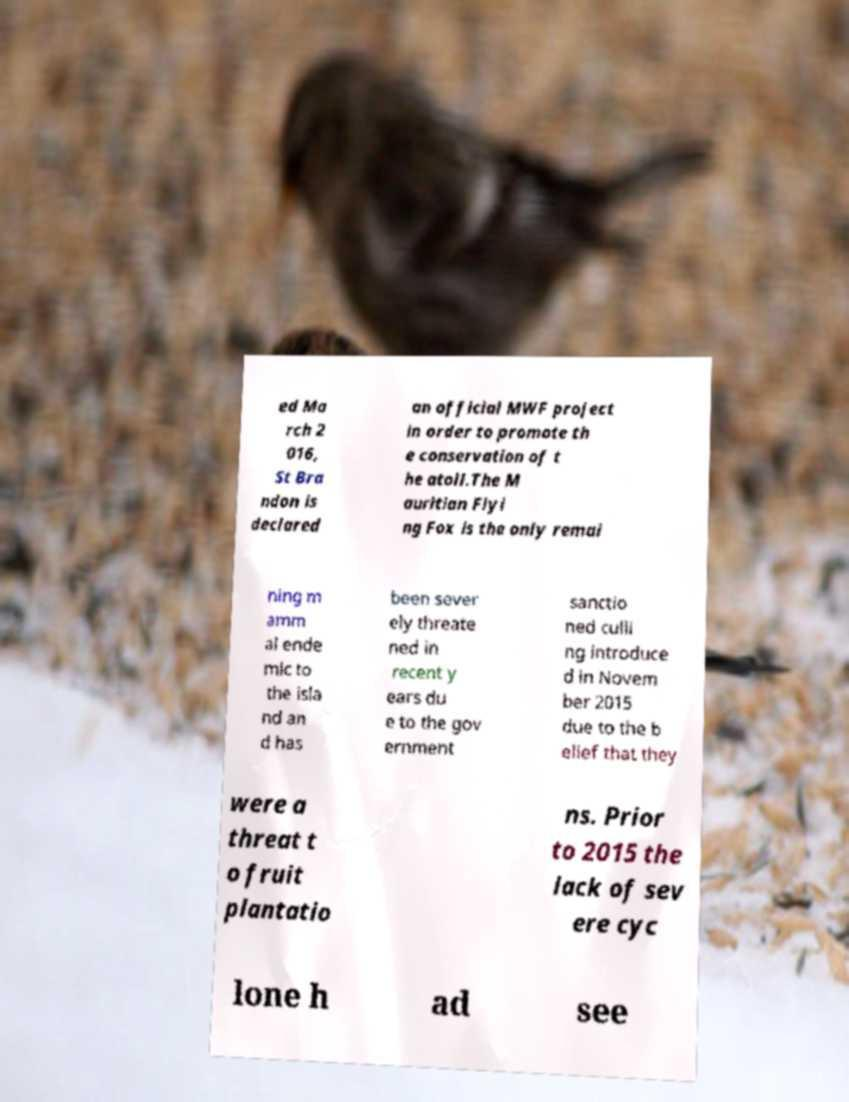Could you extract and type out the text from this image? ed Ma rch 2 016, St Bra ndon is declared an official MWF project in order to promote th e conservation of t he atoll.The M auritian Flyi ng Fox is the only remai ning m amm al ende mic to the isla nd an d has been sever ely threate ned in recent y ears du e to the gov ernment sanctio ned culli ng introduce d in Novem ber 2015 due to the b elief that they were a threat t o fruit plantatio ns. Prior to 2015 the lack of sev ere cyc lone h ad see 